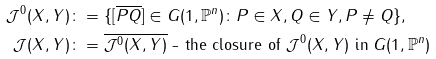Convert formula to latex. <formula><loc_0><loc_0><loc_500><loc_500>\mathcal { J } ^ { 0 } ( X , Y ) & \colon = \{ [ \overline { P Q } ] \in G ( 1 , \mathbb { P } ^ { n } ) \colon P \in X , Q \in Y , P \neq Q \} , \\ \mathcal { J } ( X , Y ) & \colon = \overline { \mathcal { J } ^ { 0 } ( X , Y ) } \text { - the closure of } \mathcal { J } ^ { 0 } ( X , Y ) \text { in } G ( 1 , \mathbb { P } ^ { n } )</formula> 